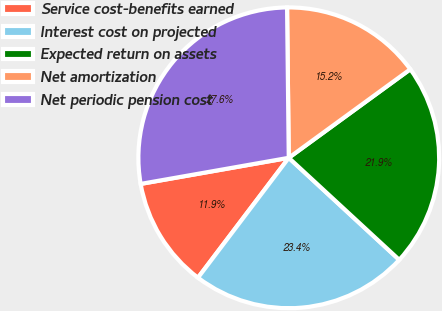Convert chart. <chart><loc_0><loc_0><loc_500><loc_500><pie_chart><fcel>Service cost-benefits earned<fcel>Interest cost on projected<fcel>Expected return on assets<fcel>Net amortization<fcel>Net periodic pension cost<nl><fcel>11.91%<fcel>23.45%<fcel>21.89%<fcel>15.16%<fcel>27.6%<nl></chart> 